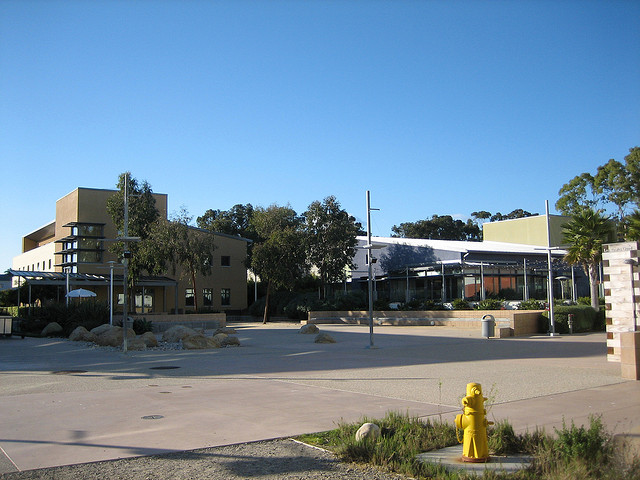How many vases are surrounding the tree? Upon examining the image closely, it appears there are no vases surrounding the tree. The area around the tree seems clear with no visible vases in sight. 